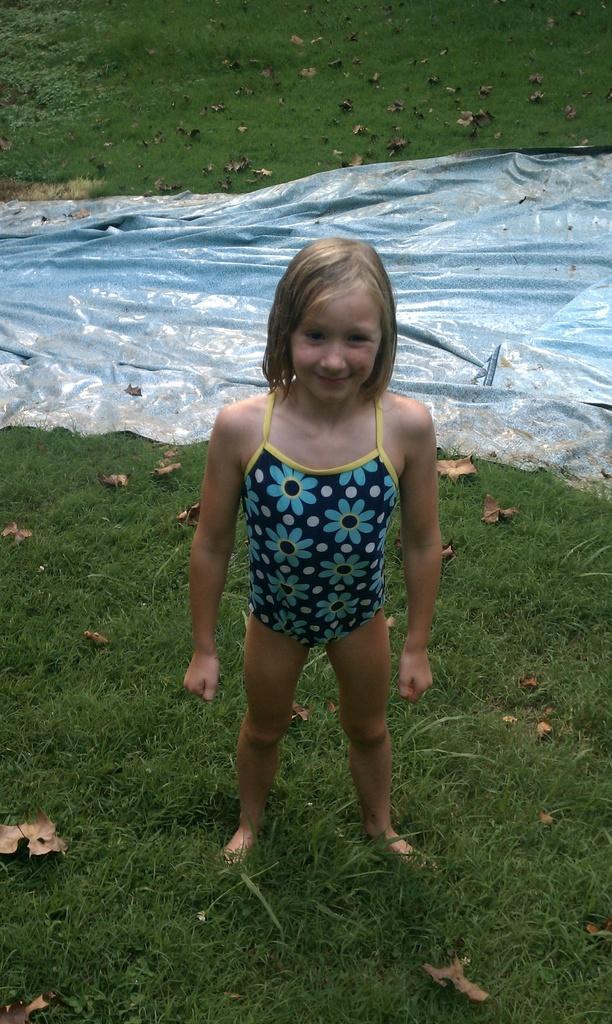Can you describe this image briefly? In this picture we can see dried leaves and tarpaulin on the green grass. In this picture we can see a person standing and smiling. 